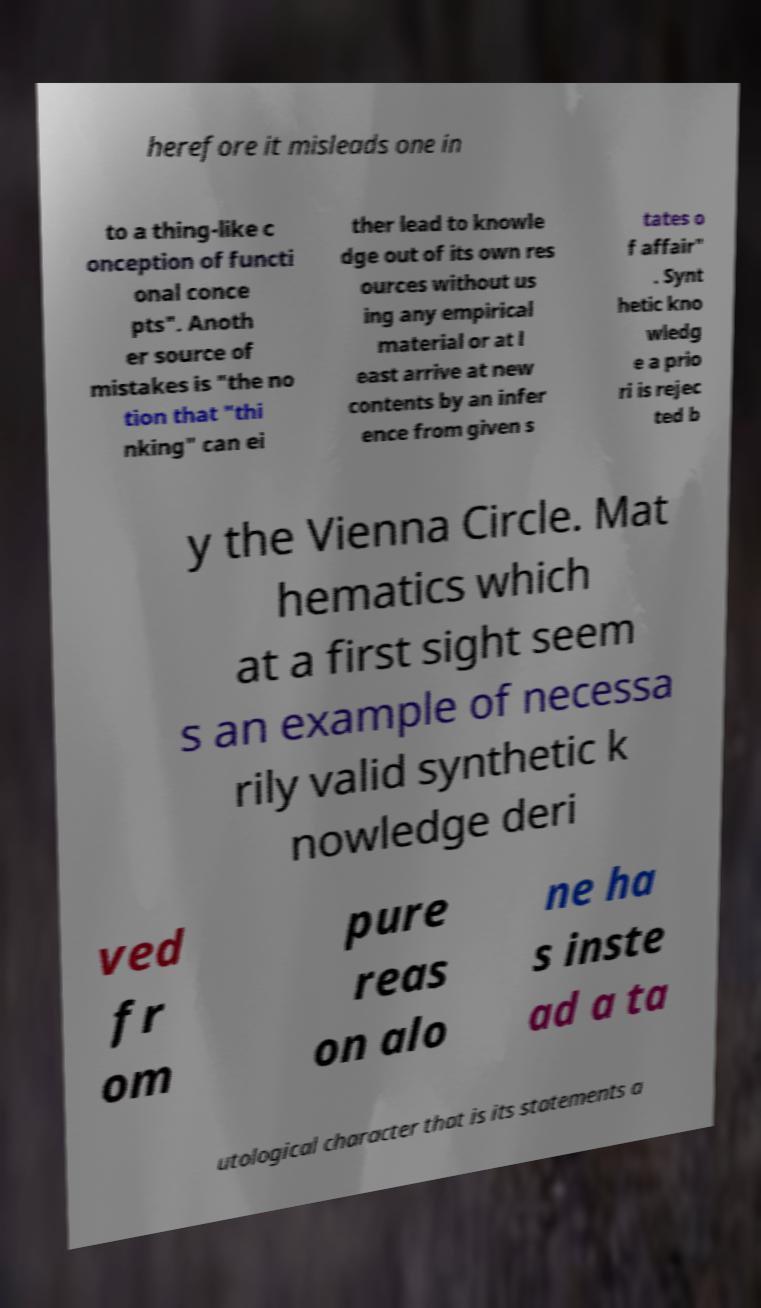Could you assist in decoding the text presented in this image and type it out clearly? herefore it misleads one in to a thing-like c onception of functi onal conce pts". Anoth er source of mistakes is "the no tion that "thi nking" can ei ther lead to knowle dge out of its own res ources without us ing any empirical material or at l east arrive at new contents by an infer ence from given s tates o f affair" . Synt hetic kno wledg e a prio ri is rejec ted b y the Vienna Circle. Mat hematics which at a first sight seem s an example of necessa rily valid synthetic k nowledge deri ved fr om pure reas on alo ne ha s inste ad a ta utological character that is its statements a 